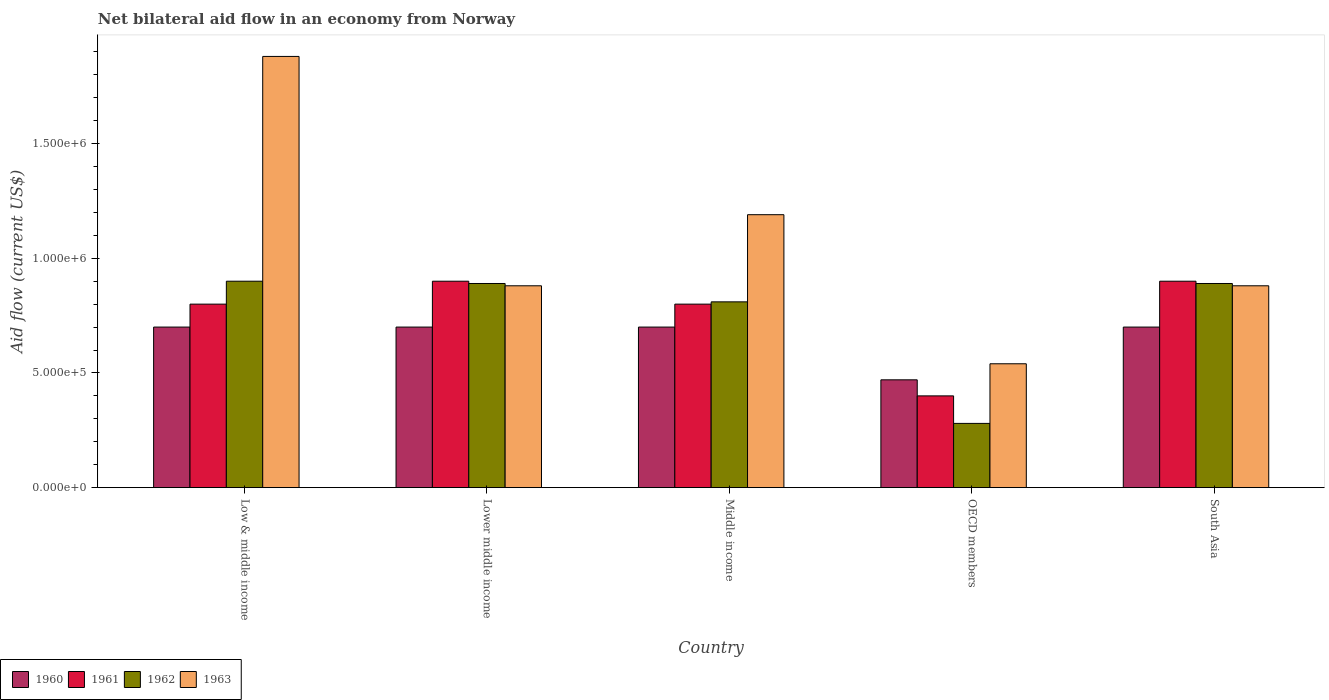What is the label of the 2nd group of bars from the left?
Your response must be concise. Lower middle income. What is the net bilateral aid flow in 1963 in Lower middle income?
Your answer should be very brief. 8.80e+05. Across all countries, what is the maximum net bilateral aid flow in 1963?
Your response must be concise. 1.88e+06. Across all countries, what is the minimum net bilateral aid flow in 1962?
Your answer should be very brief. 2.80e+05. In which country was the net bilateral aid flow in 1962 minimum?
Your response must be concise. OECD members. What is the total net bilateral aid flow in 1961 in the graph?
Ensure brevity in your answer.  3.80e+06. What is the difference between the net bilateral aid flow in 1963 in Low & middle income and that in OECD members?
Offer a terse response. 1.34e+06. What is the average net bilateral aid flow in 1962 per country?
Make the answer very short. 7.54e+05. What is the difference between the net bilateral aid flow of/in 1963 and net bilateral aid flow of/in 1960 in Low & middle income?
Give a very brief answer. 1.18e+06. What is the ratio of the net bilateral aid flow in 1961 in Lower middle income to that in South Asia?
Your answer should be compact. 1. What is the difference between the highest and the second highest net bilateral aid flow in 1962?
Your answer should be compact. 10000. What is the difference between the highest and the lowest net bilateral aid flow in 1960?
Give a very brief answer. 2.30e+05. What does the 1st bar from the left in Middle income represents?
Offer a terse response. 1960. What does the 1st bar from the right in South Asia represents?
Offer a terse response. 1963. Is it the case that in every country, the sum of the net bilateral aid flow in 1963 and net bilateral aid flow in 1960 is greater than the net bilateral aid flow in 1961?
Keep it short and to the point. Yes. How many bars are there?
Provide a succinct answer. 20. What is the difference between two consecutive major ticks on the Y-axis?
Your answer should be very brief. 5.00e+05. Are the values on the major ticks of Y-axis written in scientific E-notation?
Your answer should be very brief. Yes. Does the graph contain any zero values?
Your answer should be very brief. No. Does the graph contain grids?
Your answer should be compact. No. How many legend labels are there?
Keep it short and to the point. 4. What is the title of the graph?
Keep it short and to the point. Net bilateral aid flow in an economy from Norway. What is the Aid flow (current US$) in 1963 in Low & middle income?
Make the answer very short. 1.88e+06. What is the Aid flow (current US$) in 1962 in Lower middle income?
Your answer should be compact. 8.90e+05. What is the Aid flow (current US$) of 1963 in Lower middle income?
Ensure brevity in your answer.  8.80e+05. What is the Aid flow (current US$) in 1962 in Middle income?
Your answer should be very brief. 8.10e+05. What is the Aid flow (current US$) of 1963 in Middle income?
Your answer should be compact. 1.19e+06. What is the Aid flow (current US$) of 1961 in OECD members?
Provide a short and direct response. 4.00e+05. What is the Aid flow (current US$) of 1963 in OECD members?
Make the answer very short. 5.40e+05. What is the Aid flow (current US$) in 1960 in South Asia?
Your answer should be very brief. 7.00e+05. What is the Aid flow (current US$) in 1962 in South Asia?
Your answer should be compact. 8.90e+05. What is the Aid flow (current US$) in 1963 in South Asia?
Offer a terse response. 8.80e+05. Across all countries, what is the maximum Aid flow (current US$) in 1961?
Offer a very short reply. 9.00e+05. Across all countries, what is the maximum Aid flow (current US$) of 1962?
Your answer should be very brief. 9.00e+05. Across all countries, what is the maximum Aid flow (current US$) in 1963?
Provide a short and direct response. 1.88e+06. Across all countries, what is the minimum Aid flow (current US$) of 1960?
Keep it short and to the point. 4.70e+05. Across all countries, what is the minimum Aid flow (current US$) in 1961?
Your answer should be compact. 4.00e+05. Across all countries, what is the minimum Aid flow (current US$) of 1962?
Offer a very short reply. 2.80e+05. Across all countries, what is the minimum Aid flow (current US$) of 1963?
Your response must be concise. 5.40e+05. What is the total Aid flow (current US$) of 1960 in the graph?
Offer a terse response. 3.27e+06. What is the total Aid flow (current US$) of 1961 in the graph?
Give a very brief answer. 3.80e+06. What is the total Aid flow (current US$) of 1962 in the graph?
Your answer should be very brief. 3.77e+06. What is the total Aid flow (current US$) of 1963 in the graph?
Provide a succinct answer. 5.37e+06. What is the difference between the Aid flow (current US$) in 1962 in Low & middle income and that in Lower middle income?
Ensure brevity in your answer.  10000. What is the difference between the Aid flow (current US$) of 1963 in Low & middle income and that in Lower middle income?
Your response must be concise. 1.00e+06. What is the difference between the Aid flow (current US$) in 1963 in Low & middle income and that in Middle income?
Your response must be concise. 6.90e+05. What is the difference between the Aid flow (current US$) of 1960 in Low & middle income and that in OECD members?
Offer a very short reply. 2.30e+05. What is the difference between the Aid flow (current US$) of 1962 in Low & middle income and that in OECD members?
Make the answer very short. 6.20e+05. What is the difference between the Aid flow (current US$) of 1963 in Low & middle income and that in OECD members?
Provide a succinct answer. 1.34e+06. What is the difference between the Aid flow (current US$) of 1962 in Low & middle income and that in South Asia?
Provide a short and direct response. 10000. What is the difference between the Aid flow (current US$) of 1961 in Lower middle income and that in Middle income?
Your response must be concise. 1.00e+05. What is the difference between the Aid flow (current US$) in 1962 in Lower middle income and that in Middle income?
Your answer should be very brief. 8.00e+04. What is the difference between the Aid flow (current US$) in 1963 in Lower middle income and that in Middle income?
Your answer should be very brief. -3.10e+05. What is the difference between the Aid flow (current US$) in 1960 in Lower middle income and that in OECD members?
Make the answer very short. 2.30e+05. What is the difference between the Aid flow (current US$) of 1962 in Lower middle income and that in OECD members?
Ensure brevity in your answer.  6.10e+05. What is the difference between the Aid flow (current US$) in 1961 in Lower middle income and that in South Asia?
Keep it short and to the point. 0. What is the difference between the Aid flow (current US$) of 1963 in Lower middle income and that in South Asia?
Your answer should be compact. 0. What is the difference between the Aid flow (current US$) of 1960 in Middle income and that in OECD members?
Your response must be concise. 2.30e+05. What is the difference between the Aid flow (current US$) of 1962 in Middle income and that in OECD members?
Provide a succinct answer. 5.30e+05. What is the difference between the Aid flow (current US$) in 1963 in Middle income and that in OECD members?
Make the answer very short. 6.50e+05. What is the difference between the Aid flow (current US$) of 1961 in Middle income and that in South Asia?
Your response must be concise. -1.00e+05. What is the difference between the Aid flow (current US$) of 1963 in Middle income and that in South Asia?
Offer a very short reply. 3.10e+05. What is the difference between the Aid flow (current US$) in 1961 in OECD members and that in South Asia?
Provide a short and direct response. -5.00e+05. What is the difference between the Aid flow (current US$) of 1962 in OECD members and that in South Asia?
Provide a short and direct response. -6.10e+05. What is the difference between the Aid flow (current US$) in 1963 in OECD members and that in South Asia?
Offer a terse response. -3.40e+05. What is the difference between the Aid flow (current US$) of 1960 in Low & middle income and the Aid flow (current US$) of 1961 in Lower middle income?
Offer a very short reply. -2.00e+05. What is the difference between the Aid flow (current US$) of 1960 in Low & middle income and the Aid flow (current US$) of 1962 in Lower middle income?
Make the answer very short. -1.90e+05. What is the difference between the Aid flow (current US$) of 1960 in Low & middle income and the Aid flow (current US$) of 1963 in Lower middle income?
Ensure brevity in your answer.  -1.80e+05. What is the difference between the Aid flow (current US$) in 1961 in Low & middle income and the Aid flow (current US$) in 1962 in Lower middle income?
Ensure brevity in your answer.  -9.00e+04. What is the difference between the Aid flow (current US$) of 1960 in Low & middle income and the Aid flow (current US$) of 1961 in Middle income?
Provide a short and direct response. -1.00e+05. What is the difference between the Aid flow (current US$) of 1960 in Low & middle income and the Aid flow (current US$) of 1963 in Middle income?
Your answer should be compact. -4.90e+05. What is the difference between the Aid flow (current US$) of 1961 in Low & middle income and the Aid flow (current US$) of 1962 in Middle income?
Provide a short and direct response. -10000. What is the difference between the Aid flow (current US$) of 1961 in Low & middle income and the Aid flow (current US$) of 1963 in Middle income?
Ensure brevity in your answer.  -3.90e+05. What is the difference between the Aid flow (current US$) of 1961 in Low & middle income and the Aid flow (current US$) of 1962 in OECD members?
Make the answer very short. 5.20e+05. What is the difference between the Aid flow (current US$) in 1960 in Low & middle income and the Aid flow (current US$) in 1962 in South Asia?
Provide a succinct answer. -1.90e+05. What is the difference between the Aid flow (current US$) in 1961 in Low & middle income and the Aid flow (current US$) in 1962 in South Asia?
Your response must be concise. -9.00e+04. What is the difference between the Aid flow (current US$) in 1961 in Low & middle income and the Aid flow (current US$) in 1963 in South Asia?
Your answer should be compact. -8.00e+04. What is the difference between the Aid flow (current US$) of 1962 in Low & middle income and the Aid flow (current US$) of 1963 in South Asia?
Make the answer very short. 2.00e+04. What is the difference between the Aid flow (current US$) in 1960 in Lower middle income and the Aid flow (current US$) in 1962 in Middle income?
Ensure brevity in your answer.  -1.10e+05. What is the difference between the Aid flow (current US$) in 1960 in Lower middle income and the Aid flow (current US$) in 1963 in Middle income?
Your answer should be very brief. -4.90e+05. What is the difference between the Aid flow (current US$) of 1961 in Lower middle income and the Aid flow (current US$) of 1962 in Middle income?
Ensure brevity in your answer.  9.00e+04. What is the difference between the Aid flow (current US$) in 1962 in Lower middle income and the Aid flow (current US$) in 1963 in Middle income?
Keep it short and to the point. -3.00e+05. What is the difference between the Aid flow (current US$) in 1960 in Lower middle income and the Aid flow (current US$) in 1961 in OECD members?
Your answer should be compact. 3.00e+05. What is the difference between the Aid flow (current US$) of 1960 in Lower middle income and the Aid flow (current US$) of 1962 in OECD members?
Your response must be concise. 4.20e+05. What is the difference between the Aid flow (current US$) in 1960 in Lower middle income and the Aid flow (current US$) in 1963 in OECD members?
Your response must be concise. 1.60e+05. What is the difference between the Aid flow (current US$) in 1961 in Lower middle income and the Aid flow (current US$) in 1962 in OECD members?
Provide a succinct answer. 6.20e+05. What is the difference between the Aid flow (current US$) of 1961 in Lower middle income and the Aid flow (current US$) of 1963 in OECD members?
Offer a terse response. 3.60e+05. What is the difference between the Aid flow (current US$) of 1960 in Lower middle income and the Aid flow (current US$) of 1961 in South Asia?
Provide a succinct answer. -2.00e+05. What is the difference between the Aid flow (current US$) in 1961 in Middle income and the Aid flow (current US$) in 1962 in OECD members?
Your response must be concise. 5.20e+05. What is the difference between the Aid flow (current US$) in 1960 in Middle income and the Aid flow (current US$) in 1961 in South Asia?
Offer a very short reply. -2.00e+05. What is the difference between the Aid flow (current US$) in 1961 in Middle income and the Aid flow (current US$) in 1962 in South Asia?
Keep it short and to the point. -9.00e+04. What is the difference between the Aid flow (current US$) of 1962 in Middle income and the Aid flow (current US$) of 1963 in South Asia?
Give a very brief answer. -7.00e+04. What is the difference between the Aid flow (current US$) of 1960 in OECD members and the Aid flow (current US$) of 1961 in South Asia?
Make the answer very short. -4.30e+05. What is the difference between the Aid flow (current US$) in 1960 in OECD members and the Aid flow (current US$) in 1962 in South Asia?
Ensure brevity in your answer.  -4.20e+05. What is the difference between the Aid flow (current US$) in 1960 in OECD members and the Aid flow (current US$) in 1963 in South Asia?
Your answer should be compact. -4.10e+05. What is the difference between the Aid flow (current US$) of 1961 in OECD members and the Aid flow (current US$) of 1962 in South Asia?
Give a very brief answer. -4.90e+05. What is the difference between the Aid flow (current US$) in 1961 in OECD members and the Aid flow (current US$) in 1963 in South Asia?
Ensure brevity in your answer.  -4.80e+05. What is the difference between the Aid flow (current US$) in 1962 in OECD members and the Aid flow (current US$) in 1963 in South Asia?
Give a very brief answer. -6.00e+05. What is the average Aid flow (current US$) in 1960 per country?
Keep it short and to the point. 6.54e+05. What is the average Aid flow (current US$) in 1961 per country?
Ensure brevity in your answer.  7.60e+05. What is the average Aid flow (current US$) of 1962 per country?
Your answer should be very brief. 7.54e+05. What is the average Aid flow (current US$) in 1963 per country?
Provide a succinct answer. 1.07e+06. What is the difference between the Aid flow (current US$) of 1960 and Aid flow (current US$) of 1962 in Low & middle income?
Ensure brevity in your answer.  -2.00e+05. What is the difference between the Aid flow (current US$) of 1960 and Aid flow (current US$) of 1963 in Low & middle income?
Provide a succinct answer. -1.18e+06. What is the difference between the Aid flow (current US$) of 1961 and Aid flow (current US$) of 1963 in Low & middle income?
Give a very brief answer. -1.08e+06. What is the difference between the Aid flow (current US$) of 1962 and Aid flow (current US$) of 1963 in Low & middle income?
Give a very brief answer. -9.80e+05. What is the difference between the Aid flow (current US$) of 1960 and Aid flow (current US$) of 1961 in Lower middle income?
Ensure brevity in your answer.  -2.00e+05. What is the difference between the Aid flow (current US$) of 1961 and Aid flow (current US$) of 1962 in Lower middle income?
Provide a succinct answer. 10000. What is the difference between the Aid flow (current US$) of 1961 and Aid flow (current US$) of 1963 in Lower middle income?
Provide a short and direct response. 2.00e+04. What is the difference between the Aid flow (current US$) of 1960 and Aid flow (current US$) of 1962 in Middle income?
Your response must be concise. -1.10e+05. What is the difference between the Aid flow (current US$) in 1960 and Aid flow (current US$) in 1963 in Middle income?
Your answer should be compact. -4.90e+05. What is the difference between the Aid flow (current US$) of 1961 and Aid flow (current US$) of 1963 in Middle income?
Provide a short and direct response. -3.90e+05. What is the difference between the Aid flow (current US$) of 1962 and Aid flow (current US$) of 1963 in Middle income?
Give a very brief answer. -3.80e+05. What is the difference between the Aid flow (current US$) of 1960 and Aid flow (current US$) of 1962 in OECD members?
Make the answer very short. 1.90e+05. What is the difference between the Aid flow (current US$) in 1960 and Aid flow (current US$) in 1963 in OECD members?
Give a very brief answer. -7.00e+04. What is the difference between the Aid flow (current US$) of 1961 and Aid flow (current US$) of 1962 in OECD members?
Offer a terse response. 1.20e+05. What is the difference between the Aid flow (current US$) in 1960 and Aid flow (current US$) in 1961 in South Asia?
Your answer should be very brief. -2.00e+05. What is the difference between the Aid flow (current US$) of 1960 and Aid flow (current US$) of 1962 in South Asia?
Your response must be concise. -1.90e+05. What is the difference between the Aid flow (current US$) in 1960 and Aid flow (current US$) in 1963 in South Asia?
Keep it short and to the point. -1.80e+05. What is the difference between the Aid flow (current US$) in 1961 and Aid flow (current US$) in 1962 in South Asia?
Ensure brevity in your answer.  10000. What is the ratio of the Aid flow (current US$) of 1962 in Low & middle income to that in Lower middle income?
Your response must be concise. 1.01. What is the ratio of the Aid flow (current US$) of 1963 in Low & middle income to that in Lower middle income?
Keep it short and to the point. 2.14. What is the ratio of the Aid flow (current US$) in 1960 in Low & middle income to that in Middle income?
Provide a succinct answer. 1. What is the ratio of the Aid flow (current US$) of 1961 in Low & middle income to that in Middle income?
Give a very brief answer. 1. What is the ratio of the Aid flow (current US$) of 1962 in Low & middle income to that in Middle income?
Your answer should be very brief. 1.11. What is the ratio of the Aid flow (current US$) of 1963 in Low & middle income to that in Middle income?
Provide a short and direct response. 1.58. What is the ratio of the Aid flow (current US$) in 1960 in Low & middle income to that in OECD members?
Your answer should be compact. 1.49. What is the ratio of the Aid flow (current US$) in 1962 in Low & middle income to that in OECD members?
Give a very brief answer. 3.21. What is the ratio of the Aid flow (current US$) of 1963 in Low & middle income to that in OECD members?
Your answer should be very brief. 3.48. What is the ratio of the Aid flow (current US$) in 1960 in Low & middle income to that in South Asia?
Give a very brief answer. 1. What is the ratio of the Aid flow (current US$) of 1962 in Low & middle income to that in South Asia?
Offer a terse response. 1.01. What is the ratio of the Aid flow (current US$) in 1963 in Low & middle income to that in South Asia?
Provide a succinct answer. 2.14. What is the ratio of the Aid flow (current US$) of 1962 in Lower middle income to that in Middle income?
Give a very brief answer. 1.1. What is the ratio of the Aid flow (current US$) of 1963 in Lower middle income to that in Middle income?
Your answer should be very brief. 0.74. What is the ratio of the Aid flow (current US$) of 1960 in Lower middle income to that in OECD members?
Provide a succinct answer. 1.49. What is the ratio of the Aid flow (current US$) in 1961 in Lower middle income to that in OECD members?
Make the answer very short. 2.25. What is the ratio of the Aid flow (current US$) of 1962 in Lower middle income to that in OECD members?
Ensure brevity in your answer.  3.18. What is the ratio of the Aid flow (current US$) in 1963 in Lower middle income to that in OECD members?
Keep it short and to the point. 1.63. What is the ratio of the Aid flow (current US$) in 1960 in Lower middle income to that in South Asia?
Offer a very short reply. 1. What is the ratio of the Aid flow (current US$) of 1961 in Lower middle income to that in South Asia?
Offer a very short reply. 1. What is the ratio of the Aid flow (current US$) of 1962 in Lower middle income to that in South Asia?
Your response must be concise. 1. What is the ratio of the Aid flow (current US$) of 1963 in Lower middle income to that in South Asia?
Your answer should be very brief. 1. What is the ratio of the Aid flow (current US$) of 1960 in Middle income to that in OECD members?
Provide a succinct answer. 1.49. What is the ratio of the Aid flow (current US$) in 1962 in Middle income to that in OECD members?
Provide a succinct answer. 2.89. What is the ratio of the Aid flow (current US$) in 1963 in Middle income to that in OECD members?
Offer a terse response. 2.2. What is the ratio of the Aid flow (current US$) of 1960 in Middle income to that in South Asia?
Your answer should be very brief. 1. What is the ratio of the Aid flow (current US$) in 1961 in Middle income to that in South Asia?
Your response must be concise. 0.89. What is the ratio of the Aid flow (current US$) in 1962 in Middle income to that in South Asia?
Your answer should be very brief. 0.91. What is the ratio of the Aid flow (current US$) in 1963 in Middle income to that in South Asia?
Offer a very short reply. 1.35. What is the ratio of the Aid flow (current US$) in 1960 in OECD members to that in South Asia?
Your answer should be very brief. 0.67. What is the ratio of the Aid flow (current US$) of 1961 in OECD members to that in South Asia?
Ensure brevity in your answer.  0.44. What is the ratio of the Aid flow (current US$) in 1962 in OECD members to that in South Asia?
Make the answer very short. 0.31. What is the ratio of the Aid flow (current US$) of 1963 in OECD members to that in South Asia?
Your answer should be compact. 0.61. What is the difference between the highest and the second highest Aid flow (current US$) in 1960?
Your answer should be very brief. 0. What is the difference between the highest and the second highest Aid flow (current US$) of 1961?
Keep it short and to the point. 0. What is the difference between the highest and the second highest Aid flow (current US$) of 1962?
Provide a succinct answer. 10000. What is the difference between the highest and the second highest Aid flow (current US$) of 1963?
Provide a succinct answer. 6.90e+05. What is the difference between the highest and the lowest Aid flow (current US$) in 1961?
Provide a short and direct response. 5.00e+05. What is the difference between the highest and the lowest Aid flow (current US$) of 1962?
Provide a short and direct response. 6.20e+05. What is the difference between the highest and the lowest Aid flow (current US$) in 1963?
Provide a succinct answer. 1.34e+06. 